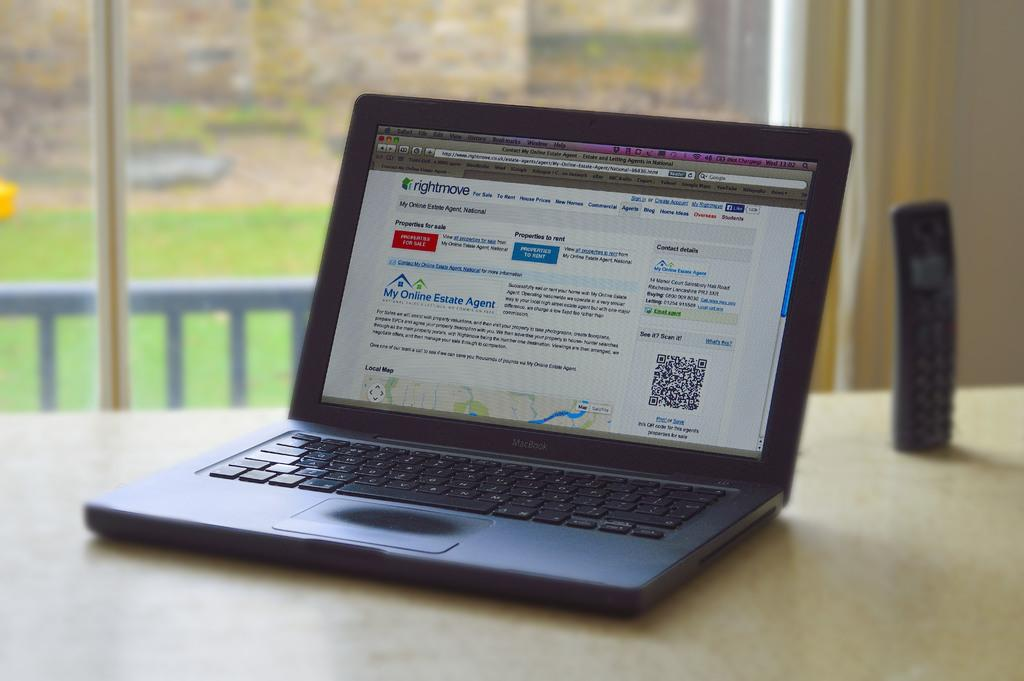<image>
Summarize the visual content of the image. a MacBook lap top computer on a table overlooking a back yard 